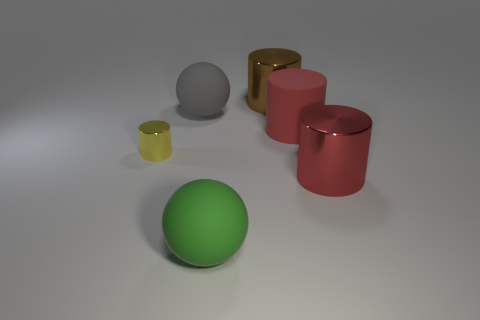Subtract all big brown metallic cylinders. How many cylinders are left? 3 Add 2 gray rubber blocks. How many objects exist? 8 Subtract all red cylinders. How many cylinders are left? 2 Subtract all cylinders. How many objects are left? 2 Subtract 2 cylinders. How many cylinders are left? 2 Add 5 large gray spheres. How many large gray spheres are left? 6 Add 5 large green rubber things. How many large green rubber things exist? 6 Subtract 0 yellow cubes. How many objects are left? 6 Subtract all yellow balls. Subtract all green blocks. How many balls are left? 2 Subtract all brown cylinders. How many green spheres are left? 1 